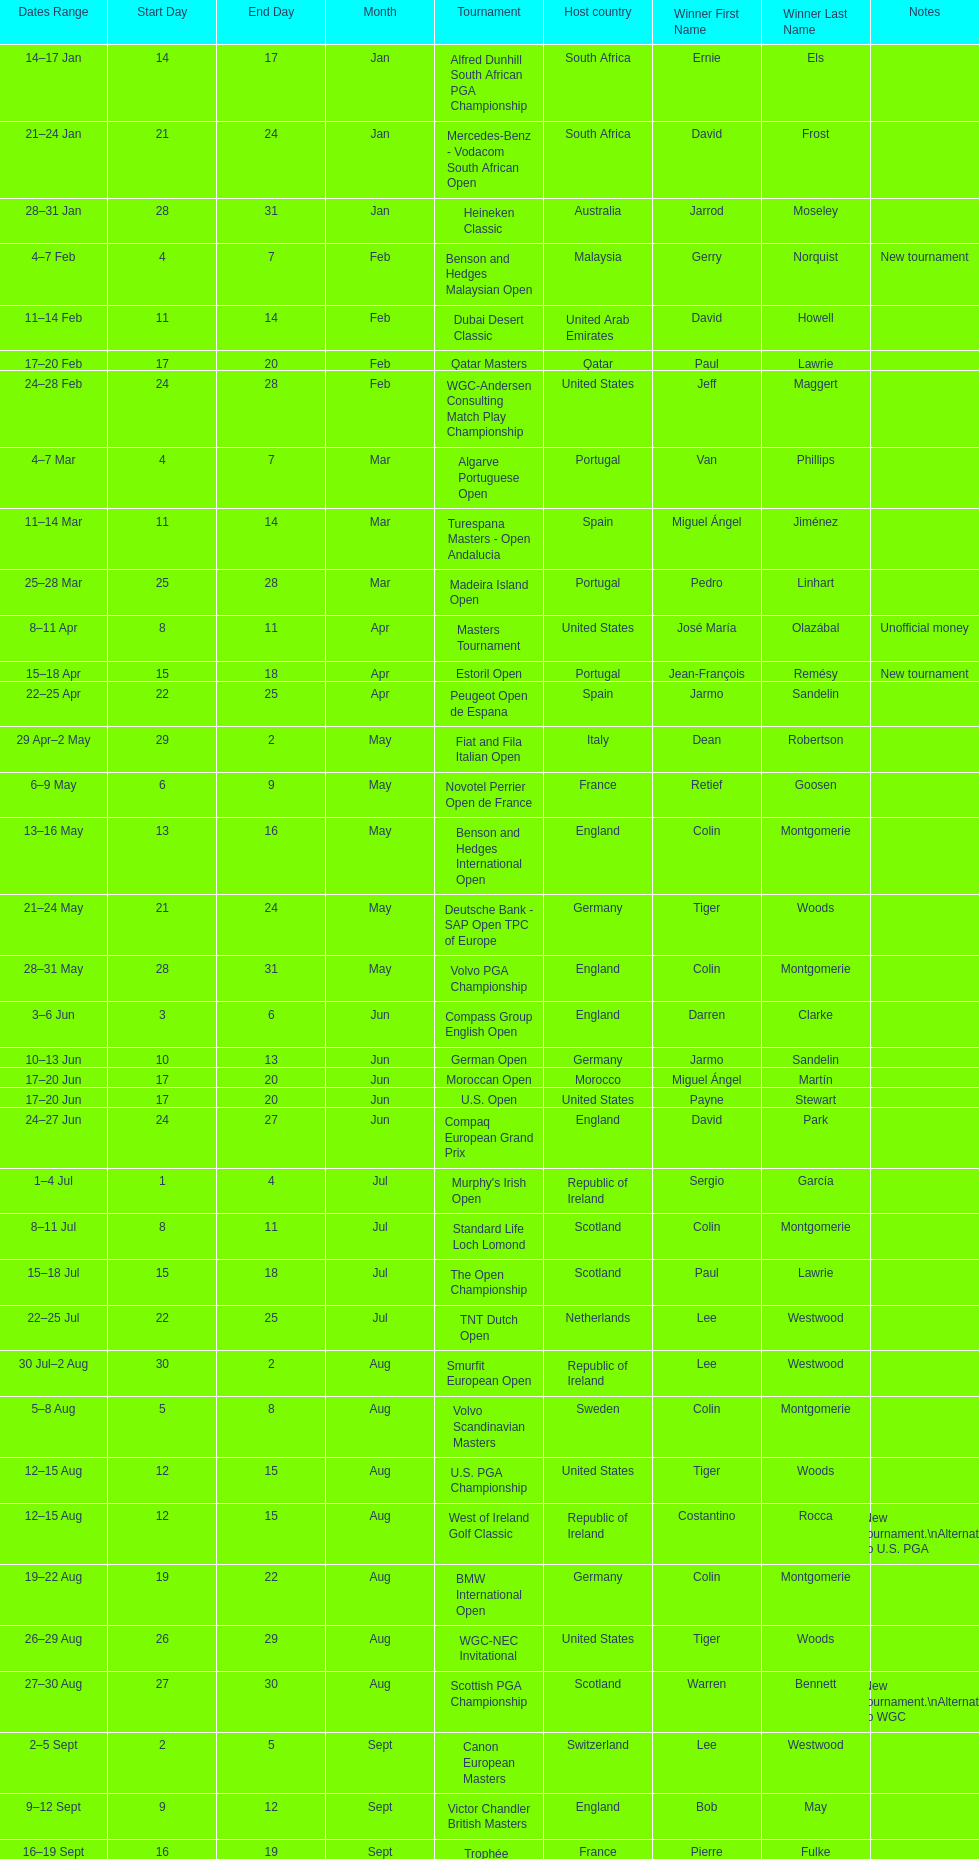What was the country listed the first time there was a new tournament? Malaysia. 